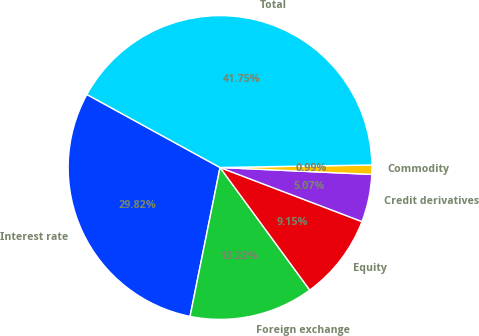<chart> <loc_0><loc_0><loc_500><loc_500><pie_chart><fcel>Interest rate<fcel>Foreign exchange<fcel>Equity<fcel>Credit derivatives<fcel>Commodity<fcel>Total<nl><fcel>29.82%<fcel>13.22%<fcel>9.15%<fcel>5.07%<fcel>0.99%<fcel>41.75%<nl></chart> 